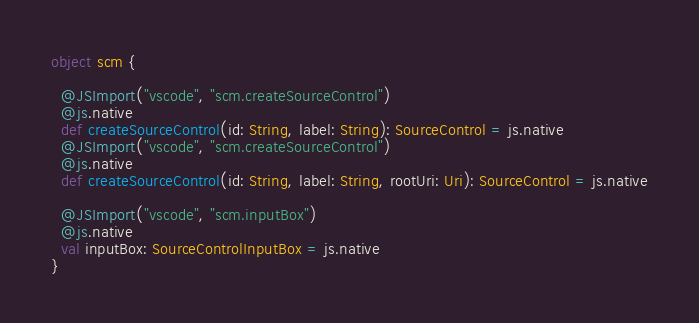Convert code to text. <code><loc_0><loc_0><loc_500><loc_500><_Scala_>
object scm {
  
  @JSImport("vscode", "scm.createSourceControl")
  @js.native
  def createSourceControl(id: String, label: String): SourceControl = js.native
  @JSImport("vscode", "scm.createSourceControl")
  @js.native
  def createSourceControl(id: String, label: String, rootUri: Uri): SourceControl = js.native
  
  @JSImport("vscode", "scm.inputBox")
  @js.native
  val inputBox: SourceControlInputBox = js.native
}
</code> 